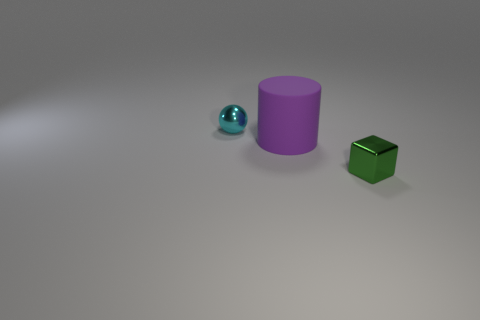Add 1 tiny green metallic things. How many objects exist? 4 Subtract all blocks. How many objects are left? 2 Add 1 blocks. How many blocks exist? 2 Subtract 0 gray spheres. How many objects are left? 3 Subtract all gray balls. Subtract all blue cylinders. How many balls are left? 1 Subtract all green cylinders. How many yellow blocks are left? 0 Subtract all tiny metallic blocks. Subtract all tiny green cubes. How many objects are left? 1 Add 1 small green things. How many small green things are left? 2 